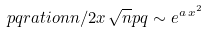<formula> <loc_0><loc_0><loc_500><loc_500>\ p q r a t i o { n } { n / 2 } { x \, \sqrt { n } } { p } { q } \sim e ^ { a \, x ^ { 2 } }</formula> 